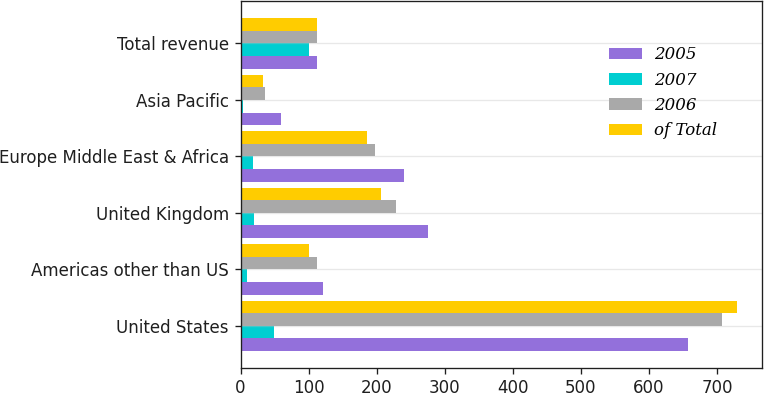<chart> <loc_0><loc_0><loc_500><loc_500><stacked_bar_chart><ecel><fcel>United States<fcel>Americas other than US<fcel>United Kingdom<fcel>Europe Middle East & Africa<fcel>Asia Pacific<fcel>Total revenue<nl><fcel>2005<fcel>657<fcel>121<fcel>275<fcel>240<fcel>59<fcel>113<nl><fcel>2007<fcel>49<fcel>9<fcel>20<fcel>18<fcel>4<fcel>100<nl><fcel>2006<fcel>708<fcel>113<fcel>228<fcel>197<fcel>36<fcel>113<nl><fcel>of Total<fcel>730<fcel>100<fcel>206<fcel>186<fcel>33<fcel>113<nl></chart> 